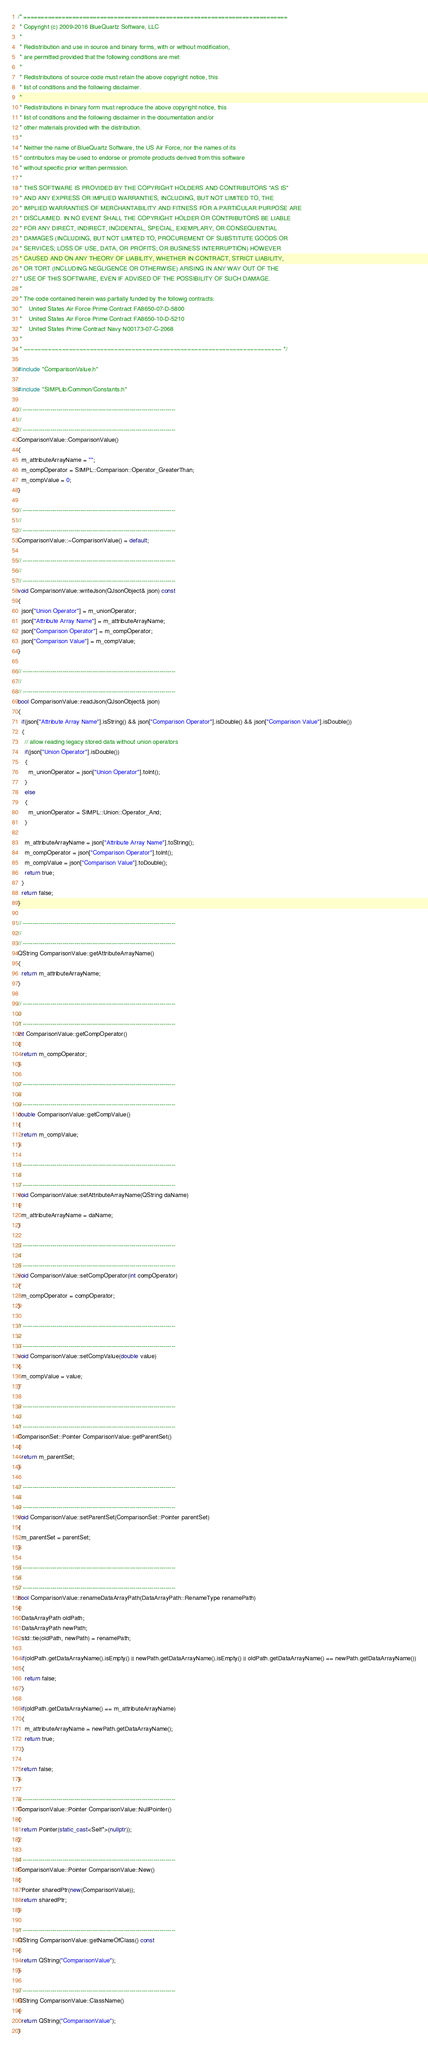<code> <loc_0><loc_0><loc_500><loc_500><_C++_>/* ============================================================================
 * Copyright (c) 2009-2016 BlueQuartz Software, LLC
 *
 * Redistribution and use in source and binary forms, with or without modification,
 * are permitted provided that the following conditions are met:
 *
 * Redistributions of source code must retain the above copyright notice, this
 * list of conditions and the following disclaimer.
 *
 * Redistributions in binary form must reproduce the above copyright notice, this
 * list of conditions and the following disclaimer in the documentation and/or
 * other materials provided with the distribution.
 *
 * Neither the name of BlueQuartz Software, the US Air Force, nor the names of its
 * contributors may be used to endorse or promote products derived from this software
 * without specific prior written permission.
 *
 * THIS SOFTWARE IS PROVIDED BY THE COPYRIGHT HOLDERS AND CONTRIBUTORS "AS IS"
 * AND ANY EXPRESS OR IMPLIED WARRANTIES, INCLUDING, BUT NOT LIMITED TO, THE
 * IMPLIED WARRANTIES OF MERCHANTABILITY AND FITNESS FOR A PARTICULAR PURPOSE ARE
 * DISCLAIMED. IN NO EVENT SHALL THE COPYRIGHT HOLDER OR CONTRIBUTORS BE LIABLE
 * FOR ANY DIRECT, INDIRECT, INCIDENTAL, SPECIAL, EXEMPLARY, OR CONSEQUENTIAL
 * DAMAGES (INCLUDING, BUT NOT LIMITED TO, PROCUREMENT OF SUBSTITUTE GOODS OR
 * SERVICES; LOSS OF USE, DATA, OR PROFITS; OR BUSINESS INTERRUPTION) HOWEVER
 * CAUSED AND ON ANY THEORY OF LIABILITY, WHETHER IN CONTRACT, STRICT LIABILITY,
 * OR TORT (INCLUDING NEGLIGENCE OR OTHERWISE) ARISING IN ANY WAY OUT OF THE
 * USE OF THIS SOFTWARE, EVEN IF ADVISED OF THE POSSIBILITY OF SUCH DAMAGE.
 *
 * The code contained herein was partially funded by the followig contracts:
 *    United States Air Force Prime Contract FA8650-07-D-5800
 *    United States Air Force Prime Contract FA8650-10-D-5210
 *    United States Prime Contract Navy N00173-07-C-2068
 *
 * ~~~~~~~~~~~~~~~~~~~~~~~~~~~~~~~~~~~~~~~~~~~~~~~~~~~~~~~~~~~~~~~~~~~~~~~~~~ */

#include "ComparisonValue.h"

#include "SIMPLib/Common/Constants.h"

// -----------------------------------------------------------------------------
//
// -----------------------------------------------------------------------------
ComparisonValue::ComparisonValue()
{
  m_attributeArrayName = "";
  m_compOperator = SIMPL::Comparison::Operator_GreaterThan;
  m_compValue = 0;
}

// -----------------------------------------------------------------------------
//
// -----------------------------------------------------------------------------
ComparisonValue::~ComparisonValue() = default;

// -----------------------------------------------------------------------------
//
// -----------------------------------------------------------------------------
void ComparisonValue::writeJson(QJsonObject& json) const
{
  json["Union Operator"] = m_unionOperator;
  json["Attribute Array Name"] = m_attributeArrayName;
  json["Comparison Operator"] = m_compOperator;
  json["Comparison Value"] = m_compValue;
}

// -----------------------------------------------------------------------------
//
// -----------------------------------------------------------------------------
bool ComparisonValue::readJson(QJsonObject& json)
{
  if(json["Attribute Array Name"].isString() && json["Comparison Operator"].isDouble() && json["Comparison Value"].isDouble())
  {
    // allow reading legacy stored data without union operators
    if(json["Union Operator"].isDouble())
    {
      m_unionOperator = json["Union Operator"].toInt();
    }
    else
    {
      m_unionOperator = SIMPL::Union::Operator_And;
    }

    m_attributeArrayName = json["Attribute Array Name"].toString();
    m_compOperator = json["Comparison Operator"].toInt();
    m_compValue = json["Comparison Value"].toDouble();
    return true;
  }
  return false;
}

// -----------------------------------------------------------------------------
//
// -----------------------------------------------------------------------------
QString ComparisonValue::getAttributeArrayName()
{
  return m_attributeArrayName;
}

// -----------------------------------------------------------------------------
//
// -----------------------------------------------------------------------------
int ComparisonValue::getCompOperator()
{
  return m_compOperator;
}

// -----------------------------------------------------------------------------
//
// -----------------------------------------------------------------------------
double ComparisonValue::getCompValue()
{
  return m_compValue;
}

// -----------------------------------------------------------------------------
//
// -----------------------------------------------------------------------------
void ComparisonValue::setAttributeArrayName(QString daName)
{
  m_attributeArrayName = daName;
}

// -----------------------------------------------------------------------------
//
// -----------------------------------------------------------------------------
void ComparisonValue::setCompOperator(int compOperator)
{
  m_compOperator = compOperator;
}

// -----------------------------------------------------------------------------
//
// -----------------------------------------------------------------------------
void ComparisonValue::setCompValue(double value)
{
  m_compValue = value;
}

// -----------------------------------------------------------------------------
//
// -----------------------------------------------------------------------------
ComparisonSet::Pointer ComparisonValue::getParentSet()
{
  return m_parentSet;
}

// -----------------------------------------------------------------------------
//
// -----------------------------------------------------------------------------
void ComparisonValue::setParentSet(ComparisonSet::Pointer parentSet)
{
  m_parentSet = parentSet;
}

// -----------------------------------------------------------------------------
//
// -----------------------------------------------------------------------------
bool ComparisonValue::renameDataArrayPath(DataArrayPath::RenameType renamePath)
{
  DataArrayPath oldPath;
  DataArrayPath newPath;
  std::tie(oldPath, newPath) = renamePath;

  if(oldPath.getDataArrayName().isEmpty() || newPath.getDataArrayName().isEmpty() || oldPath.getDataArrayName() == newPath.getDataArrayName())
  {
    return false;
  }

  if(oldPath.getDataArrayName() == m_attributeArrayName)
  {
    m_attributeArrayName = newPath.getDataArrayName();
    return true;
  }

  return false;
}

// -----------------------------------------------------------------------------
ComparisonValue::Pointer ComparisonValue::NullPointer()
{
  return Pointer(static_cast<Self*>(nullptr));
}

// -----------------------------------------------------------------------------
ComparisonValue::Pointer ComparisonValue::New()
{
  Pointer sharedPtr(new(ComparisonValue));
  return sharedPtr;
}

// -----------------------------------------------------------------------------
QString ComparisonValue::getNameOfClass() const
{
  return QString("ComparisonValue");
}

// -----------------------------------------------------------------------------
QString ComparisonValue::ClassName()
{
  return QString("ComparisonValue");
}
</code> 